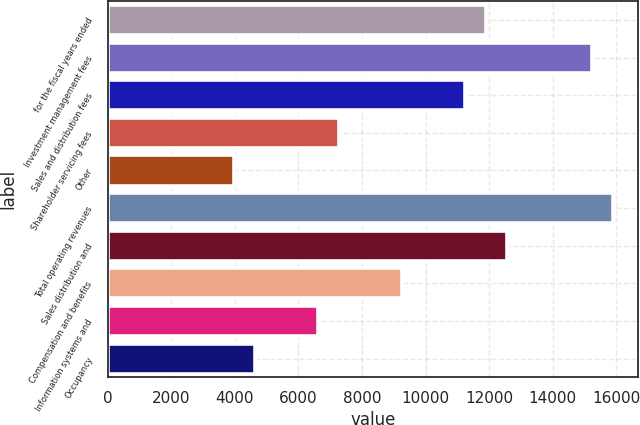<chart> <loc_0><loc_0><loc_500><loc_500><bar_chart><fcel>for the fiscal years ended<fcel>Investment management fees<fcel>Sales and distribution fees<fcel>Shareholder servicing fees<fcel>Other<fcel>Total operating revenues<fcel>Sales distribution and<fcel>Compensation and benefits<fcel>Information systems and<fcel>Occupancy<nl><fcel>11911.9<fcel>15220.5<fcel>11250.1<fcel>7279.75<fcel>3971.1<fcel>15882.2<fcel>12573.6<fcel>9264.94<fcel>6618.02<fcel>4632.83<nl></chart> 